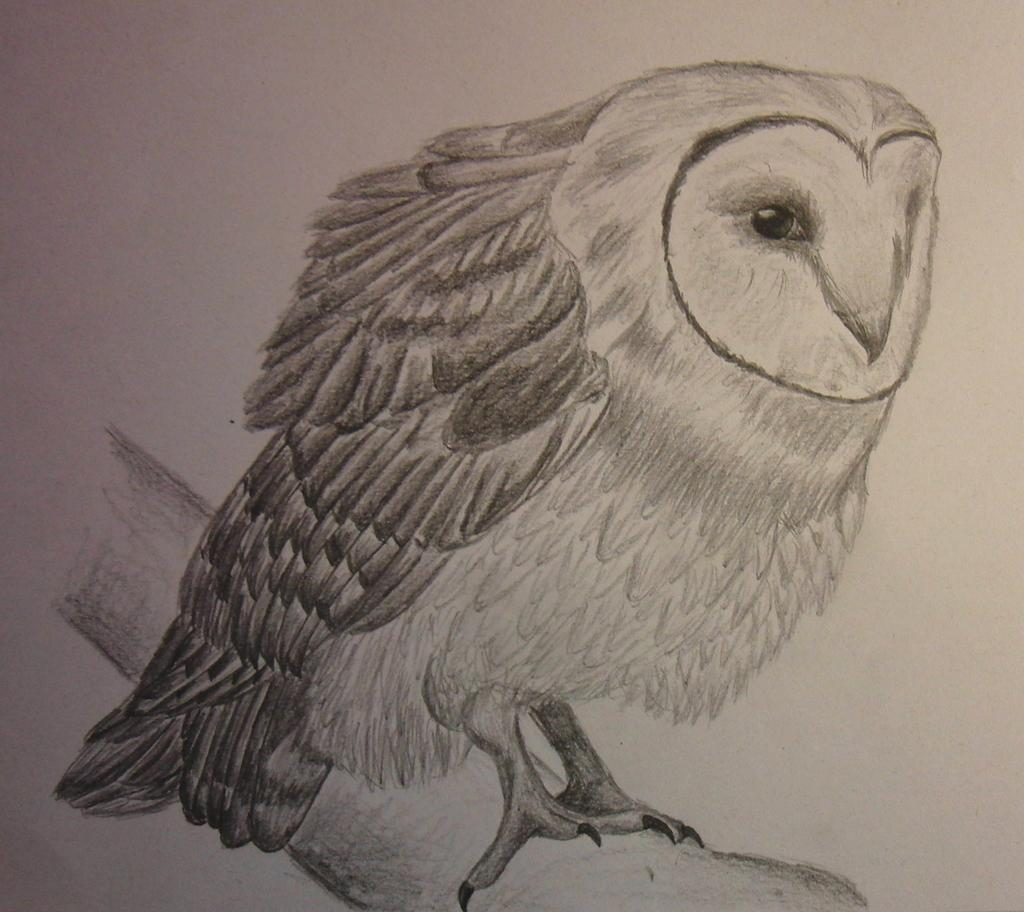What animal is featured in the image? There is an owl in the image. Where is the owl located in the image? The owl is sitting on a tree branch. What color is the background of the image? The background of the image is white. How is the image created? The image appears to be a painting. What is the owl's answer to the question about sugar in the image? There is no question about sugar in the image, and the owl does not provide any answers. 